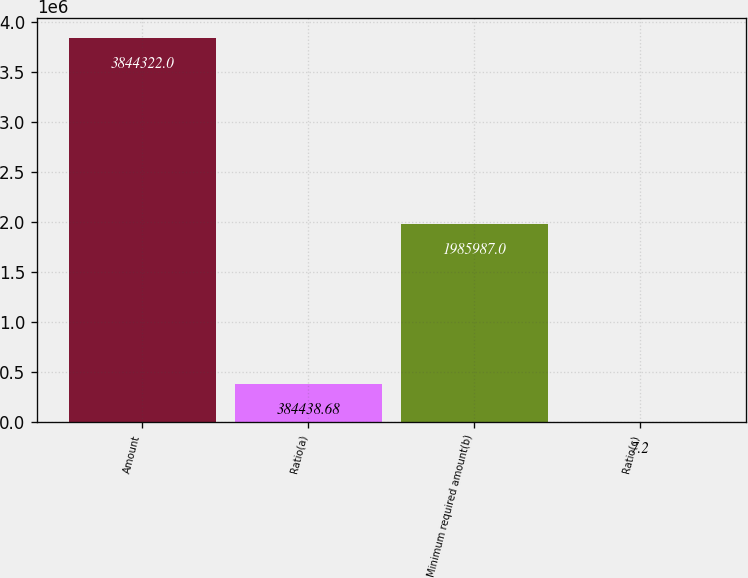Convert chart to OTSL. <chart><loc_0><loc_0><loc_500><loc_500><bar_chart><fcel>Amount<fcel>Ratio(a)<fcel>Minimum required amount(b)<fcel>Ratio(c)<nl><fcel>3.84432e+06<fcel>384439<fcel>1.98599e+06<fcel>7.2<nl></chart> 